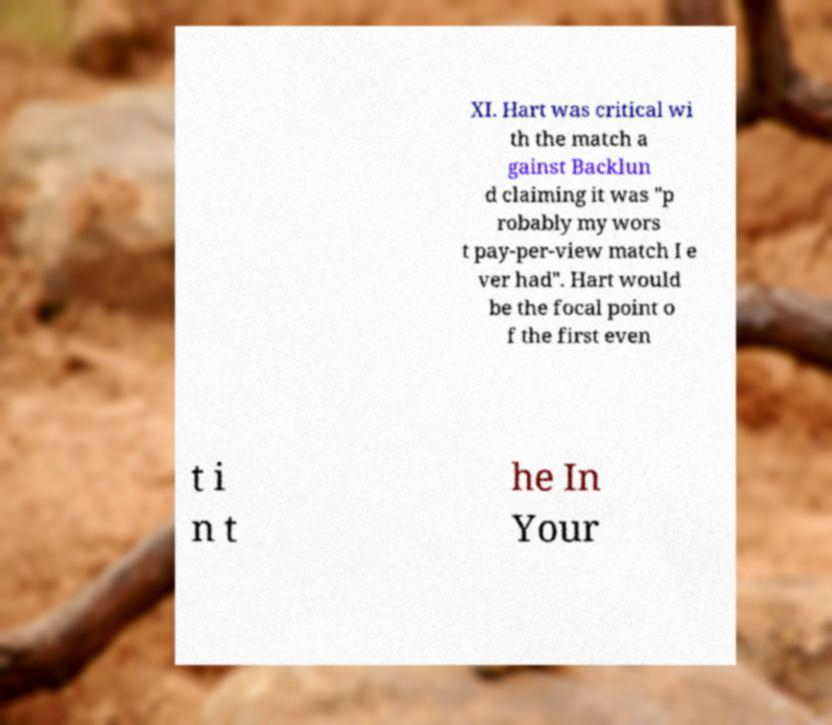For documentation purposes, I need the text within this image transcribed. Could you provide that? XI. Hart was critical wi th the match a gainst Backlun d claiming it was "p robably my wors t pay-per-view match I e ver had". Hart would be the focal point o f the first even t i n t he In Your 